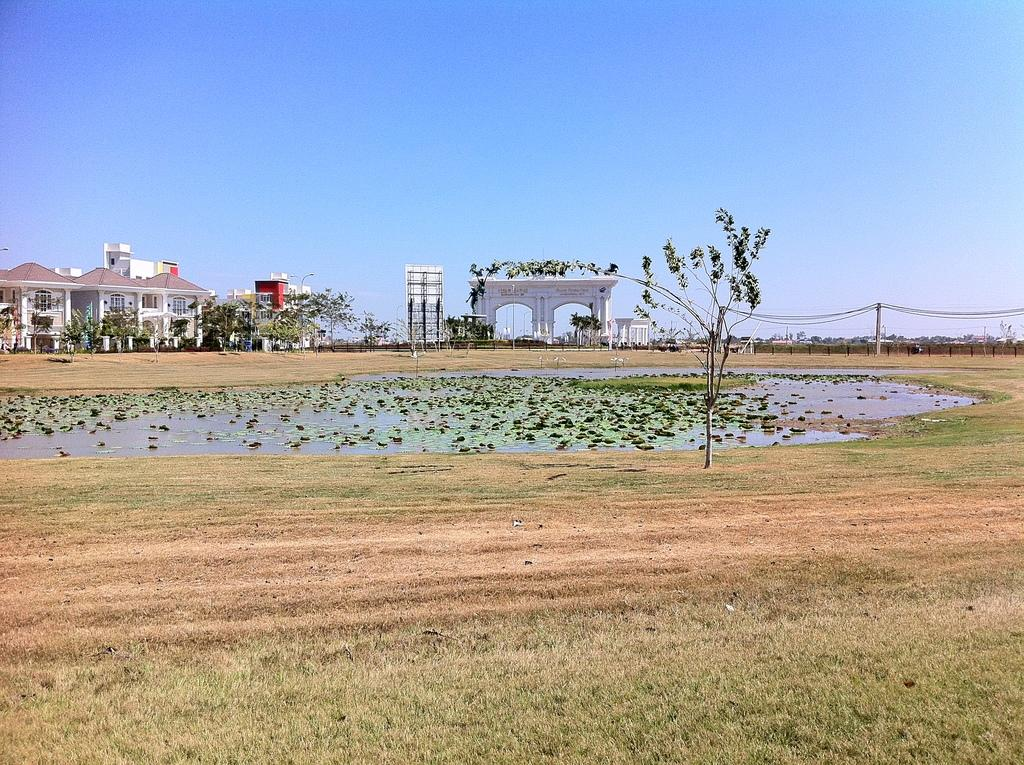What is the primary element visible in the image? There is water in the image. What type of vegetation can be seen in the image? There are trees and grass in the image. What type of structures are present in the image? There are buildings with windows in the image. What additional feature can be seen in the image? There is a hoarding in the image. What type of barrier is present in the image? There is a fence in the image. What can be seen in the background of the image? The sky is visible in the background of the image. What type of collar can be seen on the fly in the image? There is no fly or collar present in the image. What type of yarn is being used to create the trees in the image? The trees in the image are not made of yarn; they are real trees. 